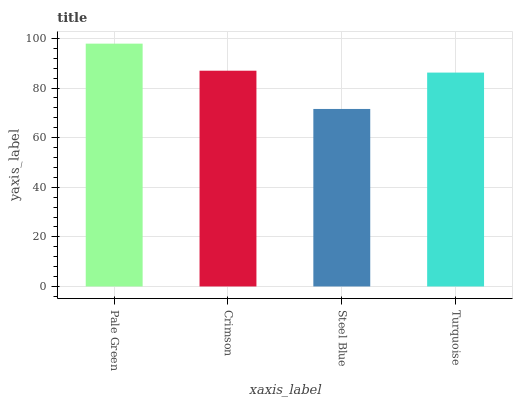Is Steel Blue the minimum?
Answer yes or no. Yes. Is Pale Green the maximum?
Answer yes or no. Yes. Is Crimson the minimum?
Answer yes or no. No. Is Crimson the maximum?
Answer yes or no. No. Is Pale Green greater than Crimson?
Answer yes or no. Yes. Is Crimson less than Pale Green?
Answer yes or no. Yes. Is Crimson greater than Pale Green?
Answer yes or no. No. Is Pale Green less than Crimson?
Answer yes or no. No. Is Crimson the high median?
Answer yes or no. Yes. Is Turquoise the low median?
Answer yes or no. Yes. Is Pale Green the high median?
Answer yes or no. No. Is Crimson the low median?
Answer yes or no. No. 